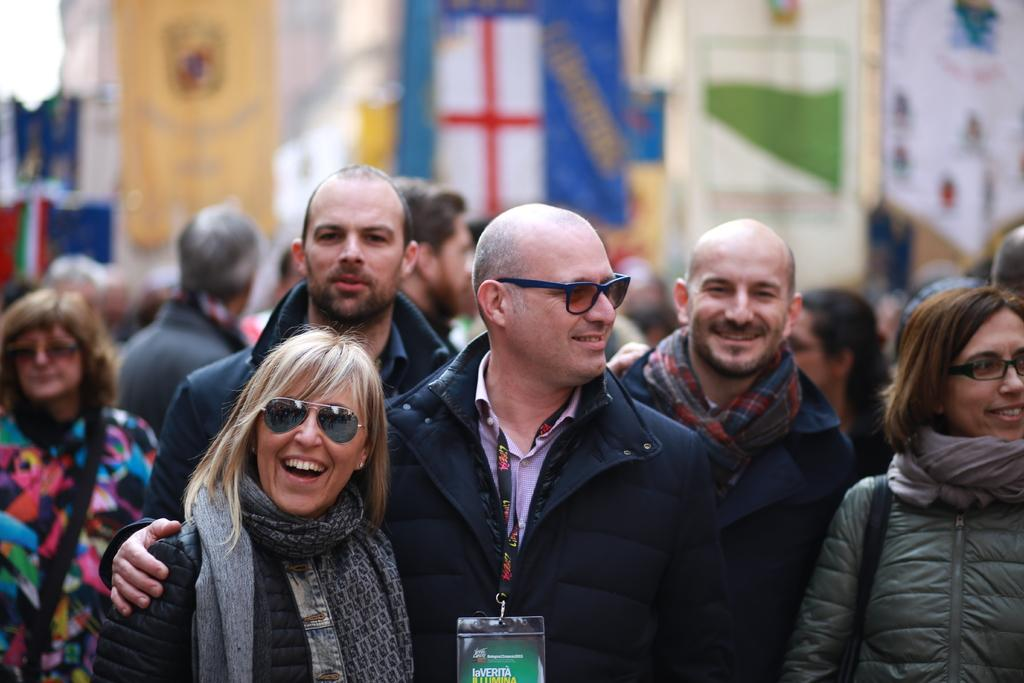Who is present in the image? There are people in the image. What is the facial expression of the people in the image? The people in the image are smiling. Can you describe the background of the image? The background of the image is blurry. Are there any other people visible in the image besides the main subjects? Yes, there are people visible in the background of the image. What type of cloud formation can be seen in the image? There is no cloud formation present in the image; it features people with a blurry background. 